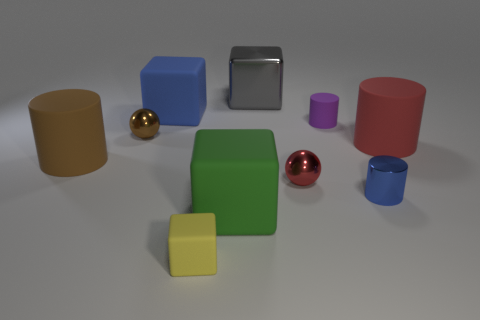How many other things are the same color as the large metallic object?
Ensure brevity in your answer.  0. Are the big cylinder that is on the right side of the purple matte cylinder and the small ball right of the big gray shiny thing made of the same material?
Offer a very short reply. No. Is the number of big rubber things that are on the right side of the big blue block the same as the number of tiny metallic things on the right side of the gray metallic thing?
Your response must be concise. Yes. What material is the small cylinder in front of the small purple object?
Your response must be concise. Metal. Is the number of red objects less than the number of gray objects?
Provide a short and direct response. No. What shape is the thing that is both behind the blue cylinder and right of the small purple matte thing?
Provide a short and direct response. Cylinder. What number of tiny red rubber blocks are there?
Offer a very short reply. 0. What is the tiny red sphere that is in front of the purple object in front of the blue object that is to the left of the green rubber object made of?
Your answer should be compact. Metal. There is a small rubber thing that is in front of the small red thing; how many tiny brown metal things are on the right side of it?
Your response must be concise. 0. There is a tiny object that is the same shape as the large gray thing; what color is it?
Your answer should be very brief. Yellow. 